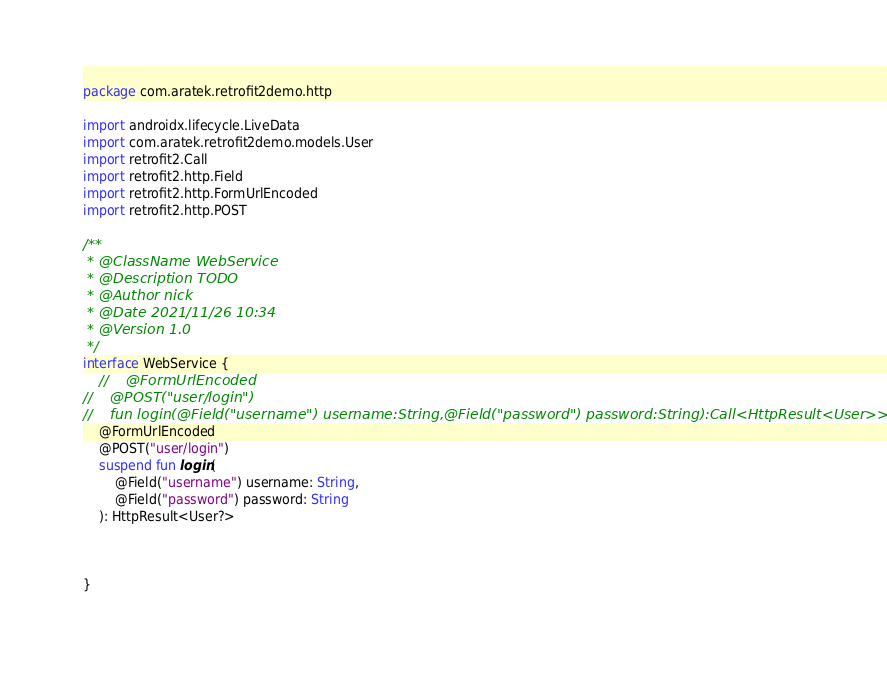<code> <loc_0><loc_0><loc_500><loc_500><_Kotlin_>package com.aratek.retrofit2demo.http

import androidx.lifecycle.LiveData
import com.aratek.retrofit2demo.models.User
import retrofit2.Call
import retrofit2.http.Field
import retrofit2.http.FormUrlEncoded
import retrofit2.http.POST

/**
 * @ClassName WebService
 * @Description TODO
 * @Author nick
 * @Date 2021/11/26 10:34
 * @Version 1.0
 */
interface WebService {
    //    @FormUrlEncoded
//    @POST("user/login")
//    fun login(@Field("username") username:String,@Field("password") password:String):Call<HttpResult<User>>
    @FormUrlEncoded
    @POST("user/login")
    suspend fun login(
        @Field("username") username: String,
        @Field("password") password: String
    ): HttpResult<User?>



}</code> 